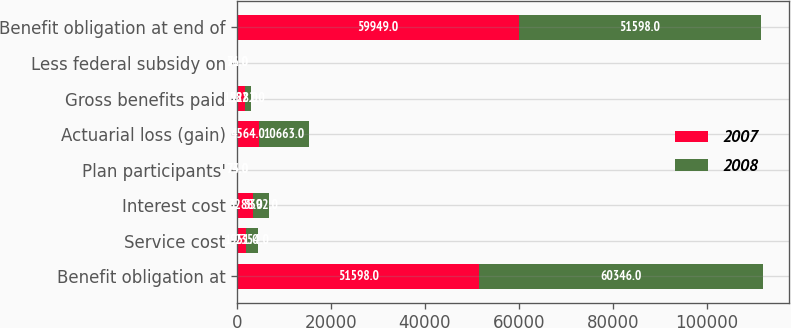<chart> <loc_0><loc_0><loc_500><loc_500><stacked_bar_chart><ecel><fcel>Benefit obligation at<fcel>Service cost<fcel>Interest cost<fcel>Plan participants'<fcel>Actuarial loss (gain)<fcel>Gross benefits paid<fcel>Less federal subsidy on<fcel>Benefit obligation at end of<nl><fcel>2007<fcel>51598<fcel>1951<fcel>3288<fcel>74<fcel>4564<fcel>1582<fcel>56<fcel>59949<nl><fcel>2008<fcel>60346<fcel>2354<fcel>3392<fcel>73<fcel>10663<fcel>1282<fcel>71<fcel>51598<nl></chart> 